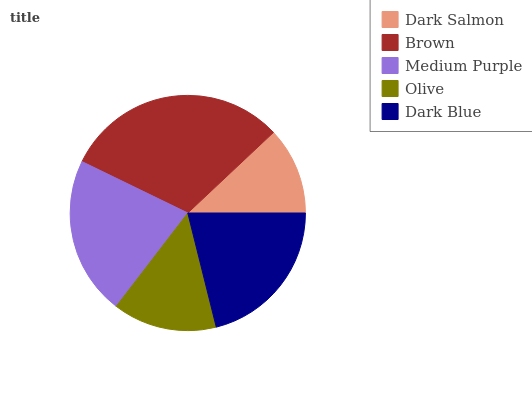Is Dark Salmon the minimum?
Answer yes or no. Yes. Is Brown the maximum?
Answer yes or no. Yes. Is Medium Purple the minimum?
Answer yes or no. No. Is Medium Purple the maximum?
Answer yes or no. No. Is Brown greater than Medium Purple?
Answer yes or no. Yes. Is Medium Purple less than Brown?
Answer yes or no. Yes. Is Medium Purple greater than Brown?
Answer yes or no. No. Is Brown less than Medium Purple?
Answer yes or no. No. Is Dark Blue the high median?
Answer yes or no. Yes. Is Dark Blue the low median?
Answer yes or no. Yes. Is Dark Salmon the high median?
Answer yes or no. No. Is Medium Purple the low median?
Answer yes or no. No. 